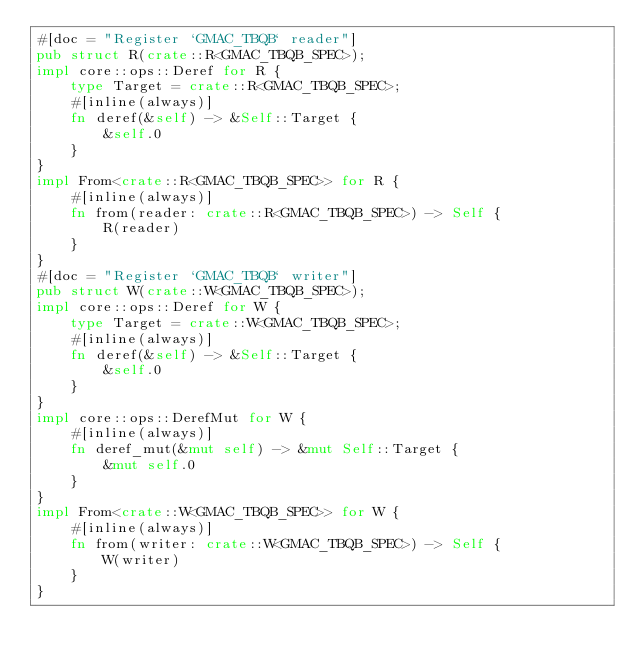<code> <loc_0><loc_0><loc_500><loc_500><_Rust_>#[doc = "Register `GMAC_TBQB` reader"]
pub struct R(crate::R<GMAC_TBQB_SPEC>);
impl core::ops::Deref for R {
    type Target = crate::R<GMAC_TBQB_SPEC>;
    #[inline(always)]
    fn deref(&self) -> &Self::Target {
        &self.0
    }
}
impl From<crate::R<GMAC_TBQB_SPEC>> for R {
    #[inline(always)]
    fn from(reader: crate::R<GMAC_TBQB_SPEC>) -> Self {
        R(reader)
    }
}
#[doc = "Register `GMAC_TBQB` writer"]
pub struct W(crate::W<GMAC_TBQB_SPEC>);
impl core::ops::Deref for W {
    type Target = crate::W<GMAC_TBQB_SPEC>;
    #[inline(always)]
    fn deref(&self) -> &Self::Target {
        &self.0
    }
}
impl core::ops::DerefMut for W {
    #[inline(always)]
    fn deref_mut(&mut self) -> &mut Self::Target {
        &mut self.0
    }
}
impl From<crate::W<GMAC_TBQB_SPEC>> for W {
    #[inline(always)]
    fn from(writer: crate::W<GMAC_TBQB_SPEC>) -> Self {
        W(writer)
    }
}</code> 